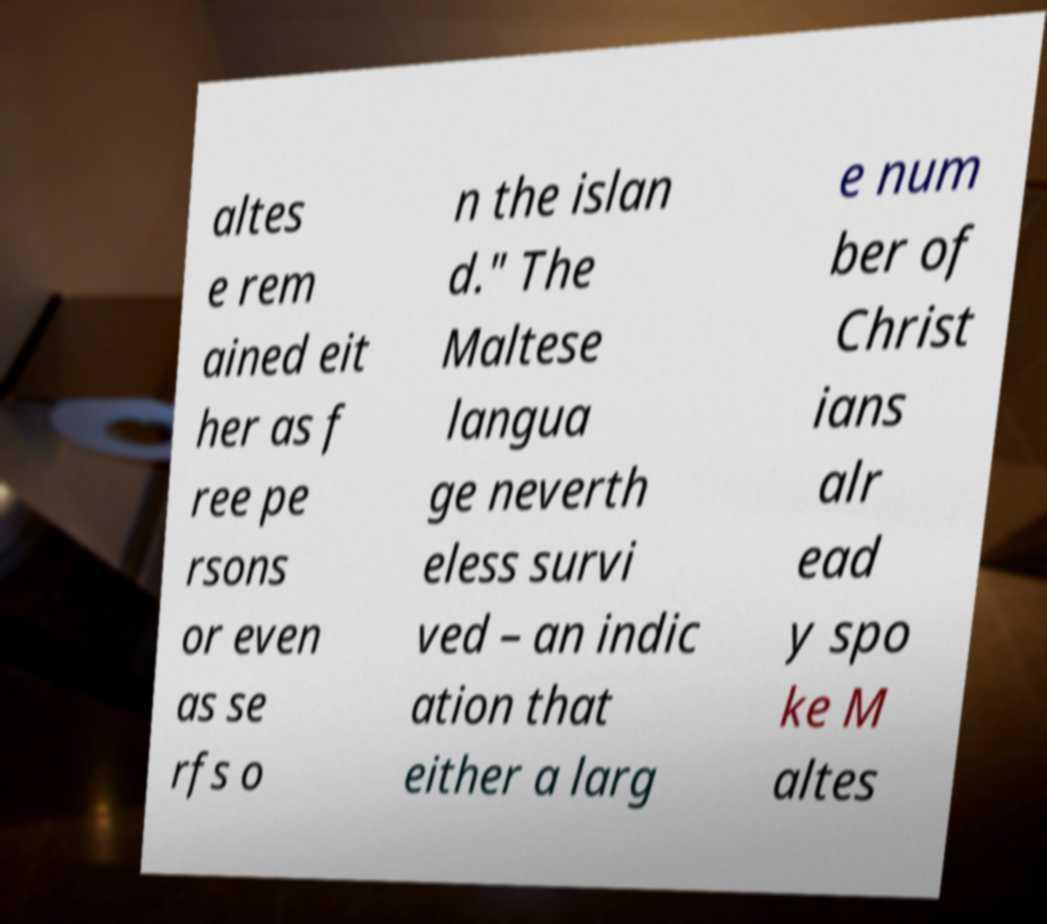Could you assist in decoding the text presented in this image and type it out clearly? altes e rem ained eit her as f ree pe rsons or even as se rfs o n the islan d." The Maltese langua ge neverth eless survi ved – an indic ation that either a larg e num ber of Christ ians alr ead y spo ke M altes 